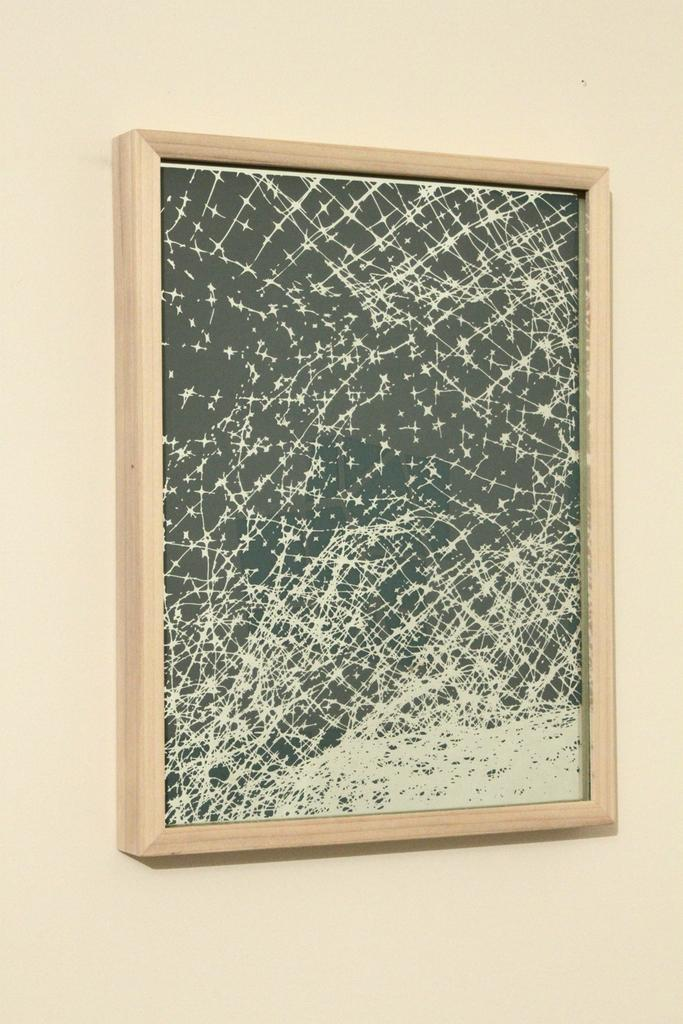What is on the wall in the image? There is a frame on the wall in the image. What type of vacation is depicted in the frame on the wall? There is no information about a vacation or any image within the frame in the given facts, so we cannot answer that question. 